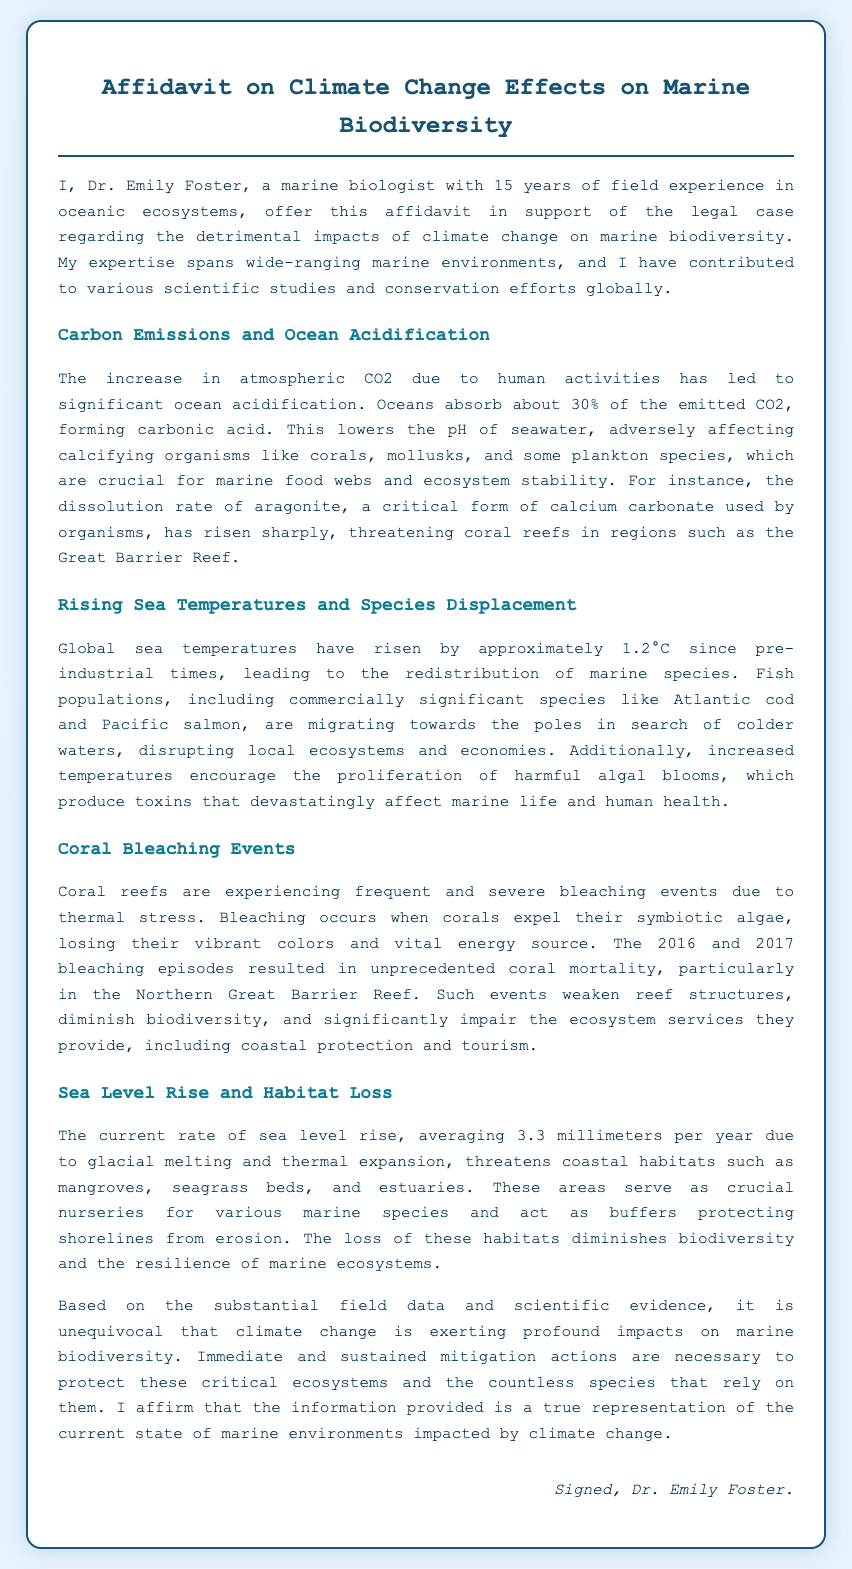What is the name of the affiant? The name of the affiant is stated at the beginning of the document, identifying the person providing the affidavit.
Answer: Dr. Emily Foster What is the focus of the affidavit? The affidavit discusses the impacts of climate change on marine biodiversity, which is the central theme of the document.
Answer: Climate Change Effects on Marine Biodiversity How many years of experience does Dr. Emily Foster have? Dr. Emily Foster's experience is detailed in the opening paragraph of the document, indicating her tenure in the field.
Answer: 15 years What percentage of CO2 emissions do oceans absorb? The document states that oceans absorb a specific percentage of emitted CO2, highlighting its significance in climate change.
Answer: 30% What has been the average rate of sea level rise per year? The document specifies the average rate of sea level rise, which emphasizes the urgency of the issue.
Answer: 3.3 millimeters Which reef experienced unprecedented coral mortality due to bleaching? The document cites a specific geographic location where severe coral bleaching occurred, emphasizing the impact of climate change.
Answer: Northern Great Barrier Reef What phenomenon occurs when corals expel their symbiotic algae? This is a specific term used in the document that describes the reaction of corals under thermal stress.
Answer: Coral Bleaching What type of organisms are particularly affected by ocean acidification? The document lists categories of organisms impacted by changing pH levels in seawater, showcasing the ecological consequences of climate change.
Answer: Calcifying organisms What is a consequence of rising sea temperatures mentioned in the affidavit? The document outlines several implications of rising sea temperatures, specifically regarding species distribution.
Answer: Species Displacement 